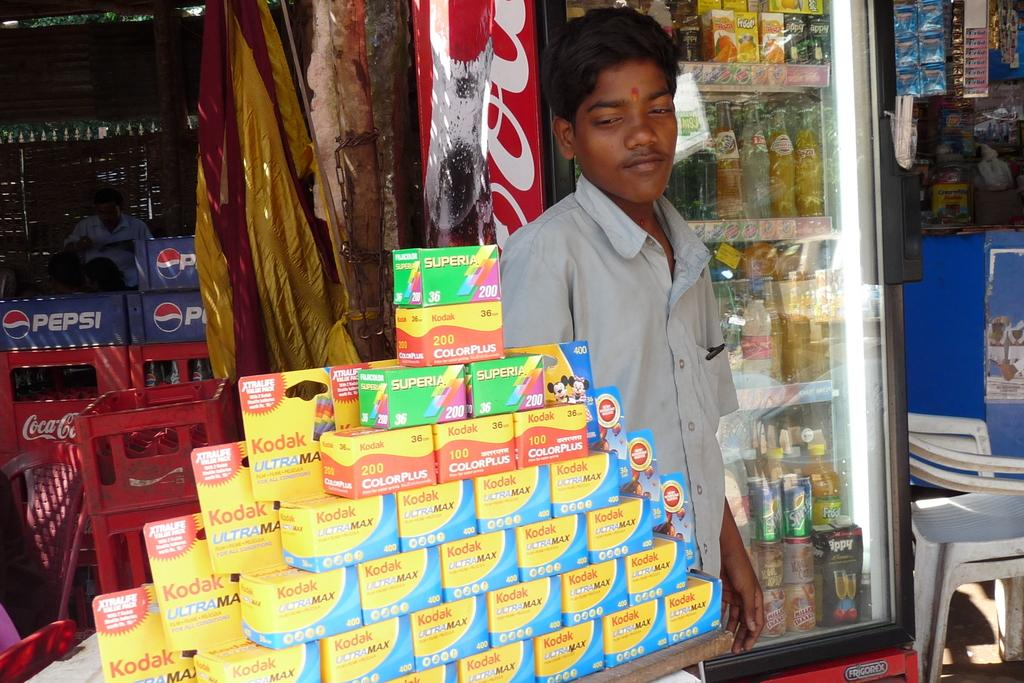Provide a one-sentence caption for the provided image. A young man standing next to a table with stacked Kodak film boxes on top. 